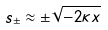Convert formula to latex. <formula><loc_0><loc_0><loc_500><loc_500>s _ { \pm } \approx \pm \sqrt { - 2 \kappa x }</formula> 